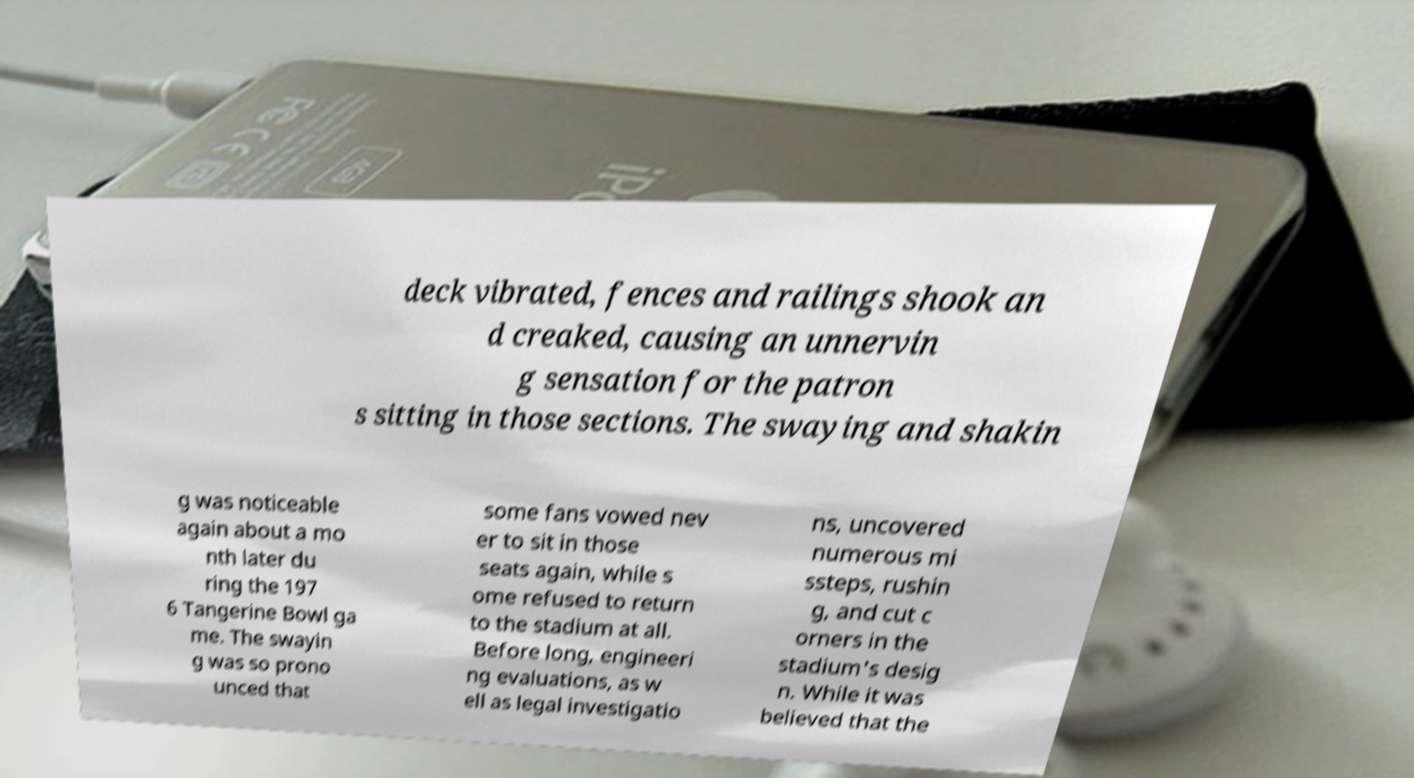There's text embedded in this image that I need extracted. Can you transcribe it verbatim? deck vibrated, fences and railings shook an d creaked, causing an unnervin g sensation for the patron s sitting in those sections. The swaying and shakin g was noticeable again about a mo nth later du ring the 197 6 Tangerine Bowl ga me. The swayin g was so prono unced that some fans vowed nev er to sit in those seats again, while s ome refused to return to the stadium at all. Before long, engineeri ng evaluations, as w ell as legal investigatio ns, uncovered numerous mi ssteps, rushin g, and cut c orners in the stadium's desig n. While it was believed that the 